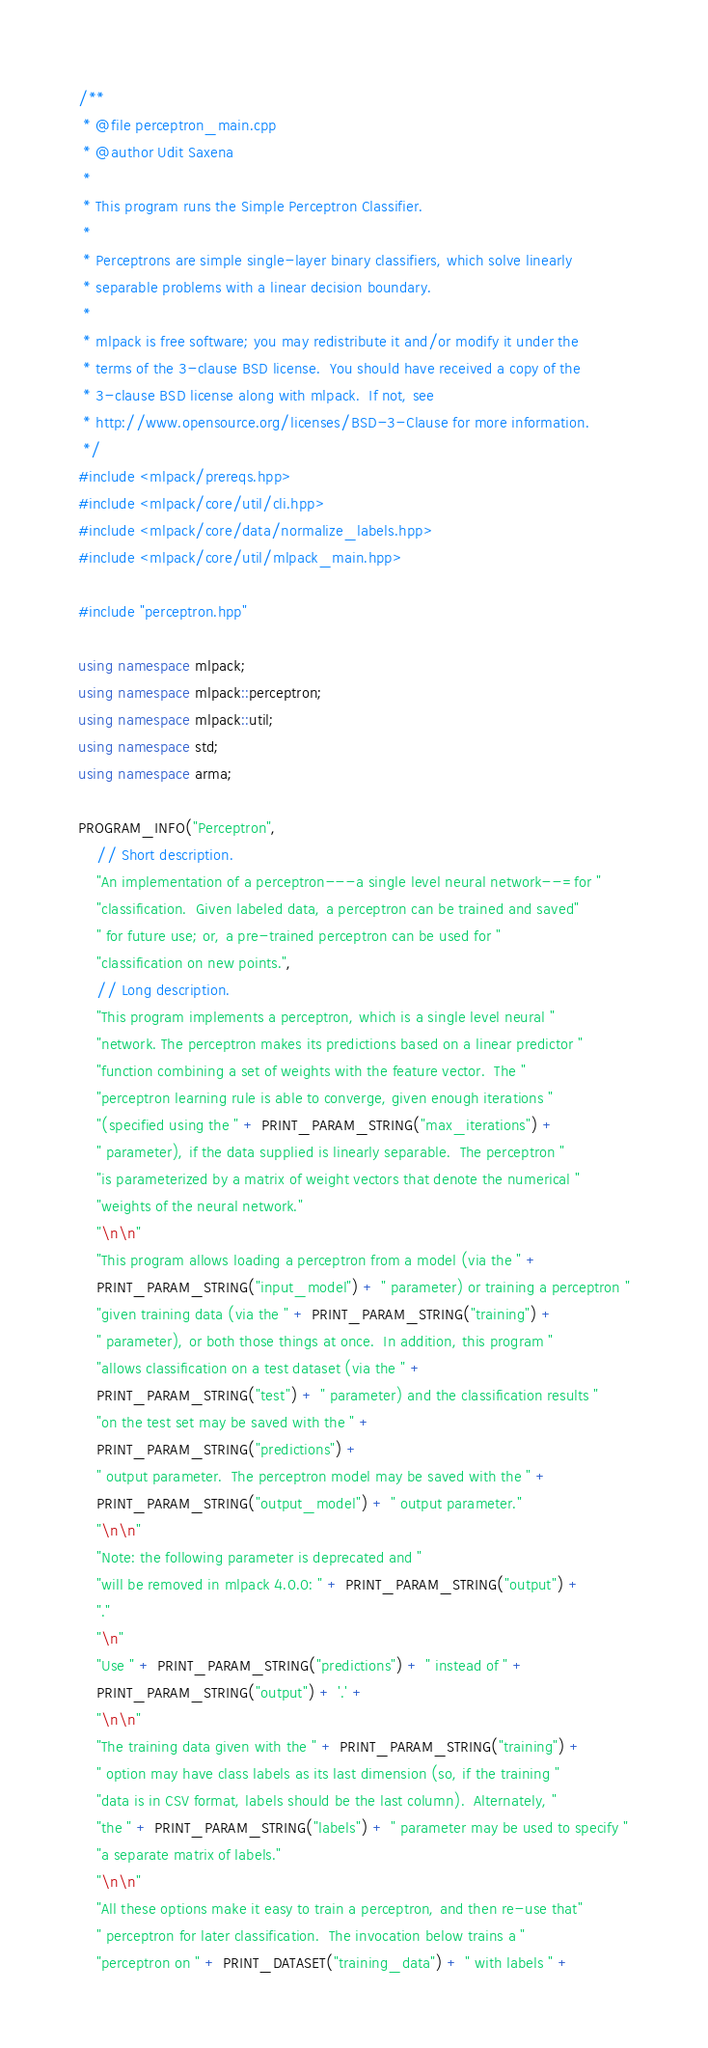<code> <loc_0><loc_0><loc_500><loc_500><_C++_>/**
 * @file perceptron_main.cpp
 * @author Udit Saxena
 *
 * This program runs the Simple Perceptron Classifier.
 *
 * Perceptrons are simple single-layer binary classifiers, which solve linearly
 * separable problems with a linear decision boundary.
 *
 * mlpack is free software; you may redistribute it and/or modify it under the
 * terms of the 3-clause BSD license.  You should have received a copy of the
 * 3-clause BSD license along with mlpack.  If not, see
 * http://www.opensource.org/licenses/BSD-3-Clause for more information.
 */
#include <mlpack/prereqs.hpp>
#include <mlpack/core/util/cli.hpp>
#include <mlpack/core/data/normalize_labels.hpp>
#include <mlpack/core/util/mlpack_main.hpp>

#include "perceptron.hpp"

using namespace mlpack;
using namespace mlpack::perceptron;
using namespace mlpack::util;
using namespace std;
using namespace arma;

PROGRAM_INFO("Perceptron",
    // Short description.
    "An implementation of a perceptron---a single level neural network--=for "
    "classification.  Given labeled data, a perceptron can be trained and saved"
    " for future use; or, a pre-trained perceptron can be used for "
    "classification on new points.",
    // Long description.
    "This program implements a perceptron, which is a single level neural "
    "network. The perceptron makes its predictions based on a linear predictor "
    "function combining a set of weights with the feature vector.  The "
    "perceptron learning rule is able to converge, given enough iterations "
    "(specified using the " + PRINT_PARAM_STRING("max_iterations") +
    " parameter), if the data supplied is linearly separable.  The perceptron "
    "is parameterized by a matrix of weight vectors that denote the numerical "
    "weights of the neural network."
    "\n\n"
    "This program allows loading a perceptron from a model (via the " +
    PRINT_PARAM_STRING("input_model") + " parameter) or training a perceptron "
    "given training data (via the " + PRINT_PARAM_STRING("training") +
    " parameter), or both those things at once.  In addition, this program "
    "allows classification on a test dataset (via the " +
    PRINT_PARAM_STRING("test") + " parameter) and the classification results "
    "on the test set may be saved with the " +
    PRINT_PARAM_STRING("predictions") +
    " output parameter.  The perceptron model may be saved with the " +
    PRINT_PARAM_STRING("output_model") + " output parameter."
    "\n\n"
    "Note: the following parameter is deprecated and "
    "will be removed in mlpack 4.0.0: " + PRINT_PARAM_STRING("output") +
    "."
    "\n"
    "Use " + PRINT_PARAM_STRING("predictions") + " instead of " +
    PRINT_PARAM_STRING("output") + '.' +
    "\n\n"
    "The training data given with the " + PRINT_PARAM_STRING("training") +
    " option may have class labels as its last dimension (so, if the training "
    "data is in CSV format, labels should be the last column).  Alternately, "
    "the " + PRINT_PARAM_STRING("labels") + " parameter may be used to specify "
    "a separate matrix of labels."
    "\n\n"
    "All these options make it easy to train a perceptron, and then re-use that"
    " perceptron for later classification.  The invocation below trains a "
    "perceptron on " + PRINT_DATASET("training_data") + " with labels " +</code> 